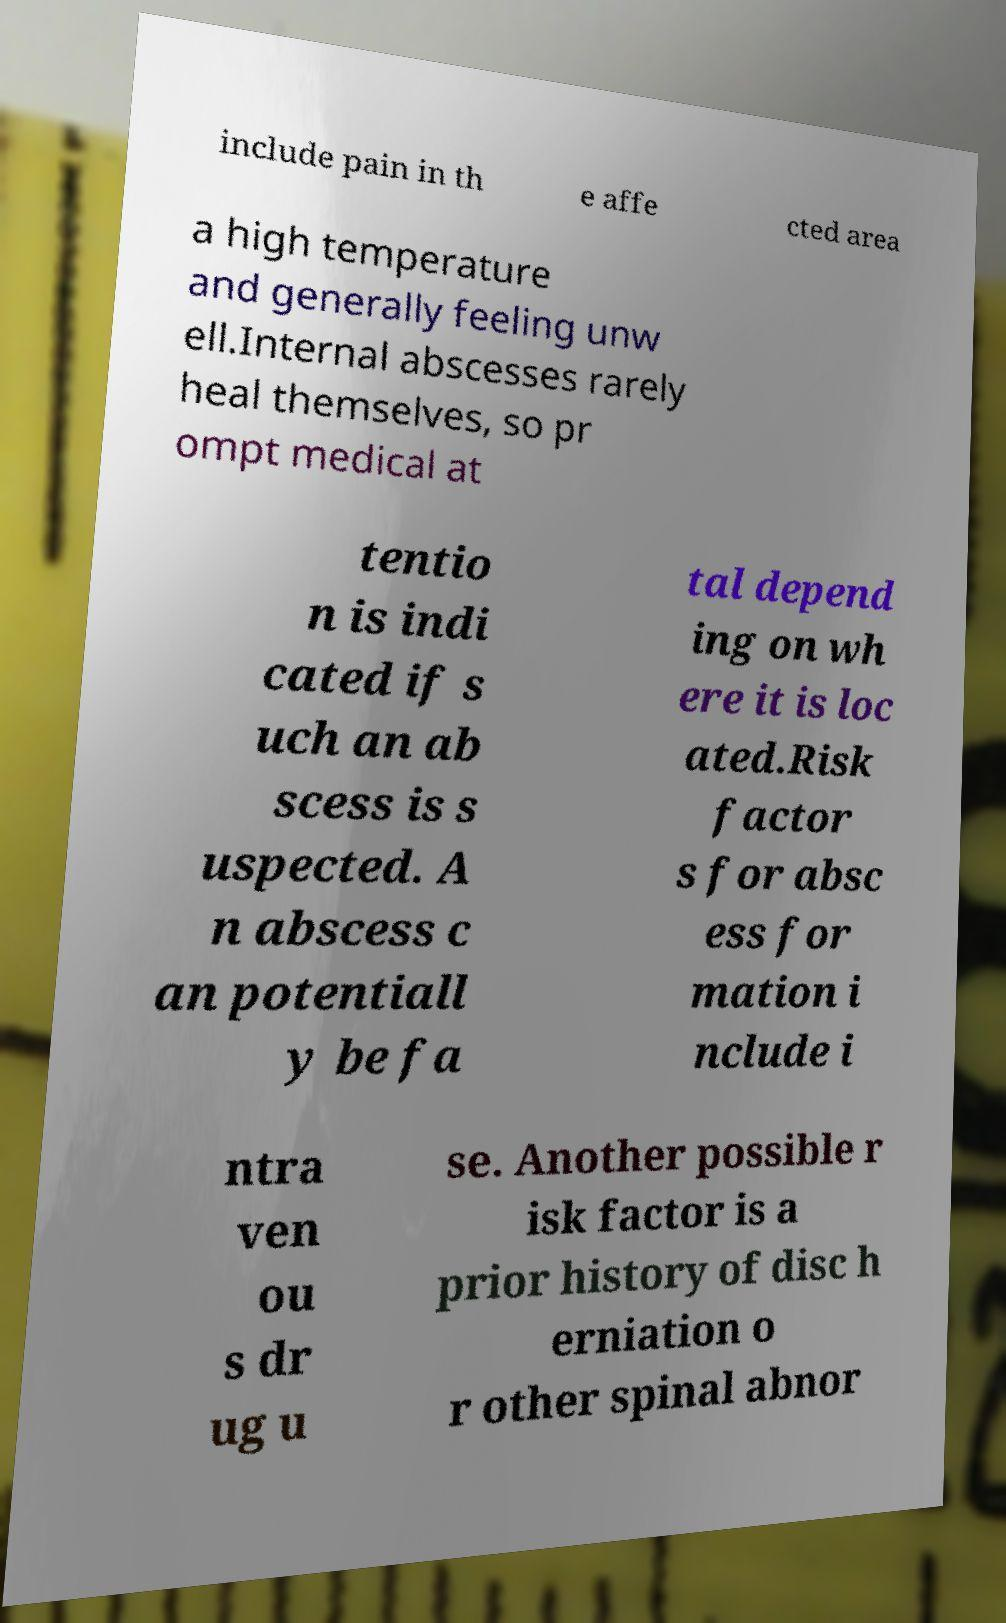I need the written content from this picture converted into text. Can you do that? include pain in th e affe cted area a high temperature and generally feeling unw ell.Internal abscesses rarely heal themselves, so pr ompt medical at tentio n is indi cated if s uch an ab scess is s uspected. A n abscess c an potentiall y be fa tal depend ing on wh ere it is loc ated.Risk factor s for absc ess for mation i nclude i ntra ven ou s dr ug u se. Another possible r isk factor is a prior history of disc h erniation o r other spinal abnor 